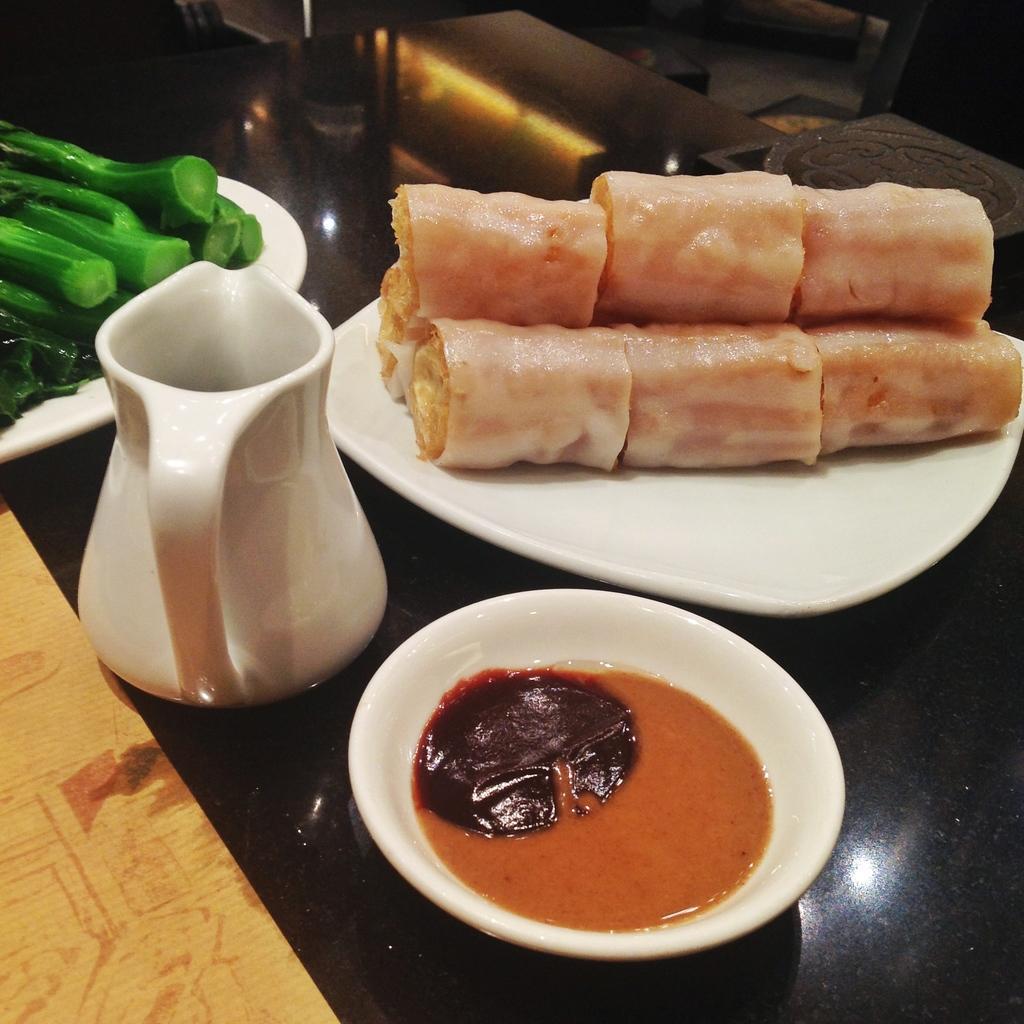In one or two sentences, can you explain what this image depicts? In this image we can see food items in a plate. There is a bowl with some sauce in it. There is a jar. There is a another plate with food items on the black color surface. 